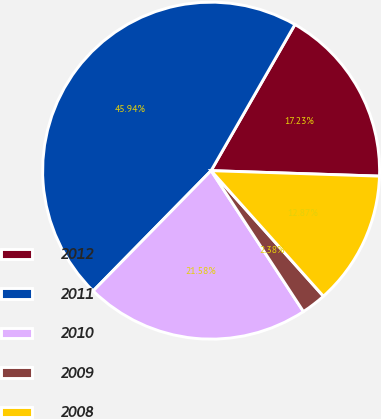Convert chart to OTSL. <chart><loc_0><loc_0><loc_500><loc_500><pie_chart><fcel>2012<fcel>2011<fcel>2010<fcel>2009<fcel>2008<nl><fcel>17.23%<fcel>45.94%<fcel>21.58%<fcel>2.38%<fcel>12.87%<nl></chart> 